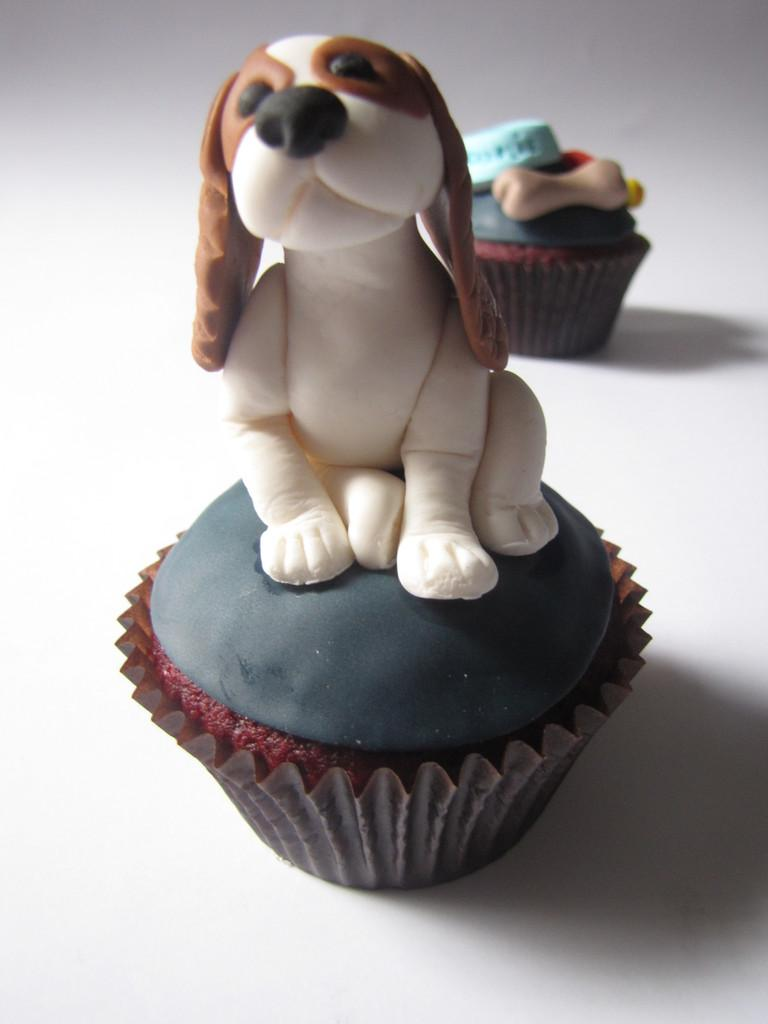What type of food can be seen in the image? There are cupcakes in the image. Can you describe the appearance of the cupcakes? The cupcakes appear to be colorful and decorated with frosting. Are there any other objects or elements in the image besides the cupcakes? The provided facts do not mention any other objects or elements in the image. What type of vessel is used to transport the houses in the image? There are no houses or vessels present in the image; it only features cupcakes. Can you describe the behavior of the robin in the image? A: There is no robin present in the image; it only features cupcakes. 